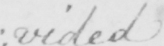What does this handwritten line say? : vided . 